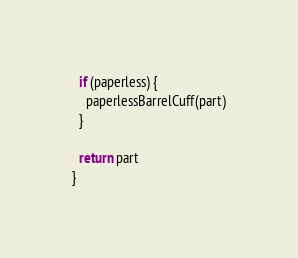<code> <loc_0><loc_0><loc_500><loc_500><_JavaScript_>  if (paperless) {
    paperlessBarrelCuff(part)
  }

  return part
}
</code> 